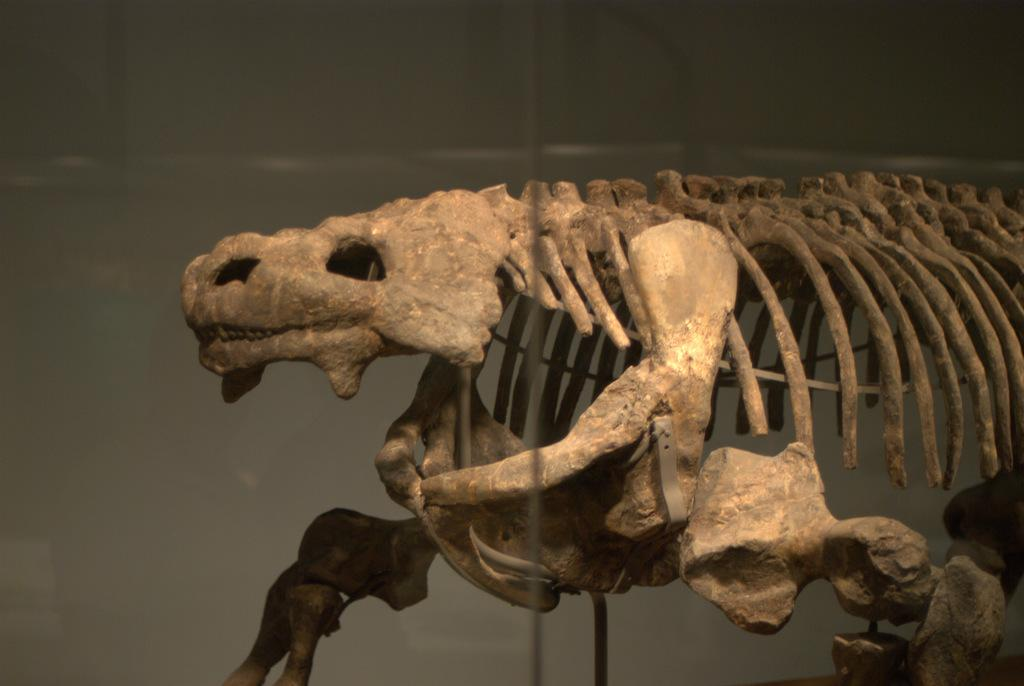What is the main subject of the image? The main subject of the image is a skeleton of an animal. What language is the skeleton speaking in the image? The skeleton is not speaking in the image, as it is a static representation of an animal's skeleton. 